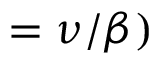<formula> <loc_0><loc_0><loc_500><loc_500>= \nu / \beta )</formula> 